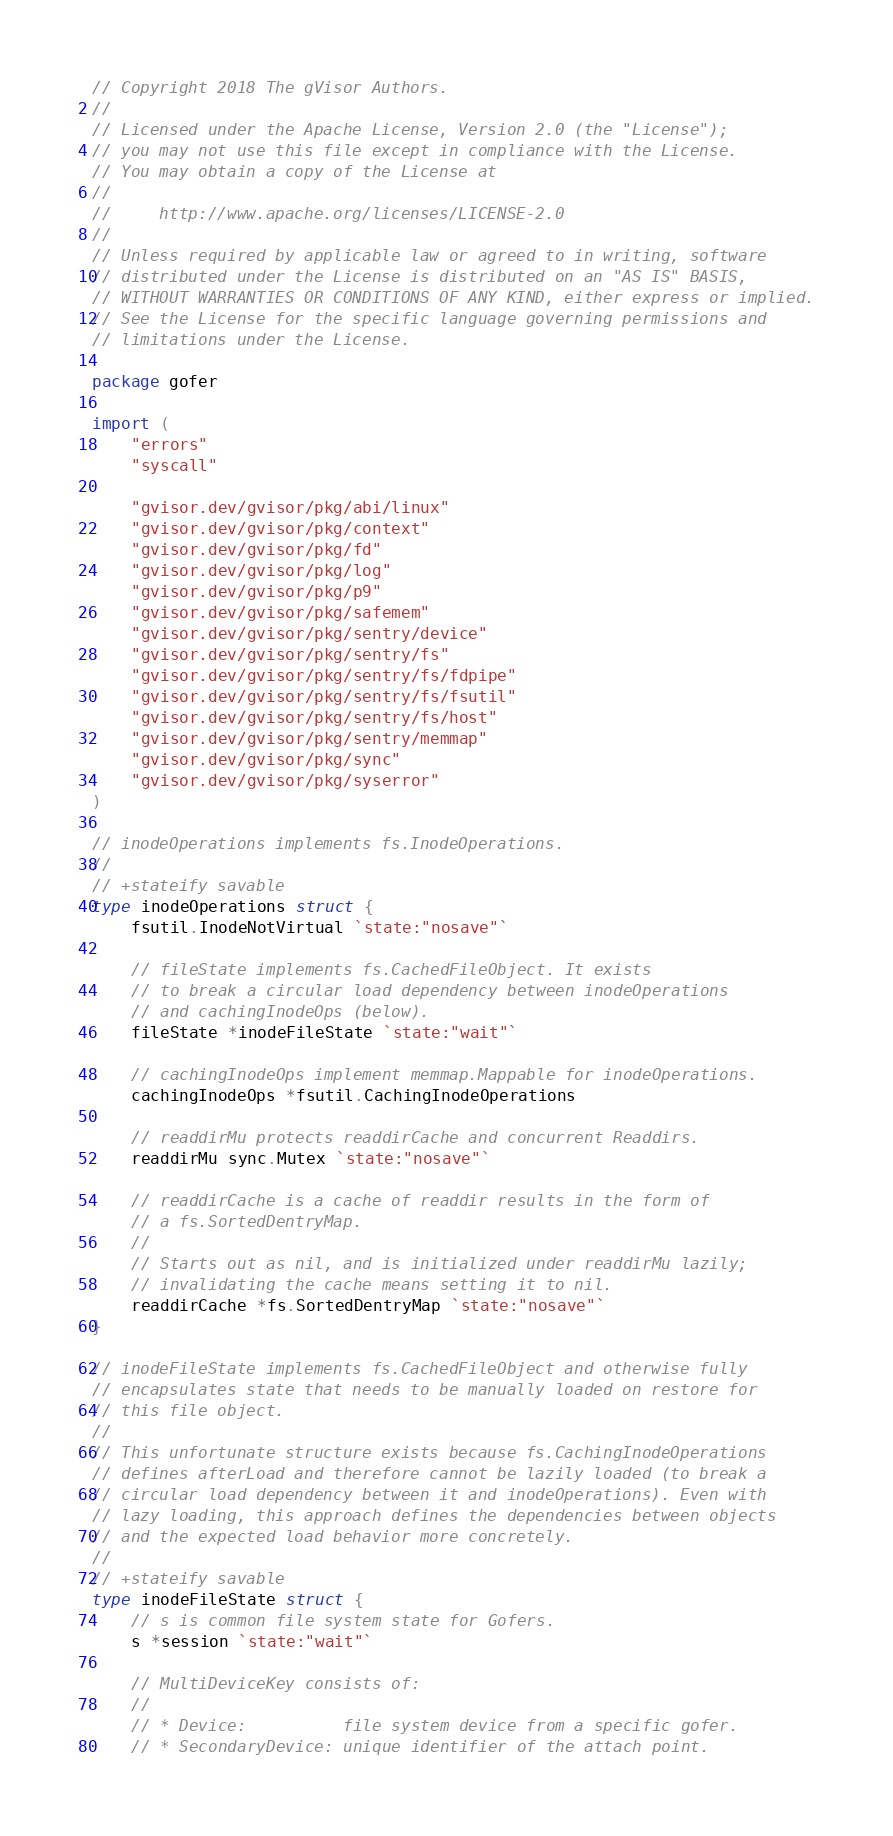<code> <loc_0><loc_0><loc_500><loc_500><_Go_>// Copyright 2018 The gVisor Authors.
//
// Licensed under the Apache License, Version 2.0 (the "License");
// you may not use this file except in compliance with the License.
// You may obtain a copy of the License at
//
//     http://www.apache.org/licenses/LICENSE-2.0
//
// Unless required by applicable law or agreed to in writing, software
// distributed under the License is distributed on an "AS IS" BASIS,
// WITHOUT WARRANTIES OR CONDITIONS OF ANY KIND, either express or implied.
// See the License for the specific language governing permissions and
// limitations under the License.

package gofer

import (
	"errors"
	"syscall"

	"gvisor.dev/gvisor/pkg/abi/linux"
	"gvisor.dev/gvisor/pkg/context"
	"gvisor.dev/gvisor/pkg/fd"
	"gvisor.dev/gvisor/pkg/log"
	"gvisor.dev/gvisor/pkg/p9"
	"gvisor.dev/gvisor/pkg/safemem"
	"gvisor.dev/gvisor/pkg/sentry/device"
	"gvisor.dev/gvisor/pkg/sentry/fs"
	"gvisor.dev/gvisor/pkg/sentry/fs/fdpipe"
	"gvisor.dev/gvisor/pkg/sentry/fs/fsutil"
	"gvisor.dev/gvisor/pkg/sentry/fs/host"
	"gvisor.dev/gvisor/pkg/sentry/memmap"
	"gvisor.dev/gvisor/pkg/sync"
	"gvisor.dev/gvisor/pkg/syserror"
)

// inodeOperations implements fs.InodeOperations.
//
// +stateify savable
type inodeOperations struct {
	fsutil.InodeNotVirtual `state:"nosave"`

	// fileState implements fs.CachedFileObject. It exists
	// to break a circular load dependency between inodeOperations
	// and cachingInodeOps (below).
	fileState *inodeFileState `state:"wait"`

	// cachingInodeOps implement memmap.Mappable for inodeOperations.
	cachingInodeOps *fsutil.CachingInodeOperations

	// readdirMu protects readdirCache and concurrent Readdirs.
	readdirMu sync.Mutex `state:"nosave"`

	// readdirCache is a cache of readdir results in the form of
	// a fs.SortedDentryMap.
	//
	// Starts out as nil, and is initialized under readdirMu lazily;
	// invalidating the cache means setting it to nil.
	readdirCache *fs.SortedDentryMap `state:"nosave"`
}

// inodeFileState implements fs.CachedFileObject and otherwise fully
// encapsulates state that needs to be manually loaded on restore for
// this file object.
//
// This unfortunate structure exists because fs.CachingInodeOperations
// defines afterLoad and therefore cannot be lazily loaded (to break a
// circular load dependency between it and inodeOperations). Even with
// lazy loading, this approach defines the dependencies between objects
// and the expected load behavior more concretely.
//
// +stateify savable
type inodeFileState struct {
	// s is common file system state for Gofers.
	s *session `state:"wait"`

	// MultiDeviceKey consists of:
	//
	// * Device:          file system device from a specific gofer.
	// * SecondaryDevice: unique identifier of the attach point.</code> 